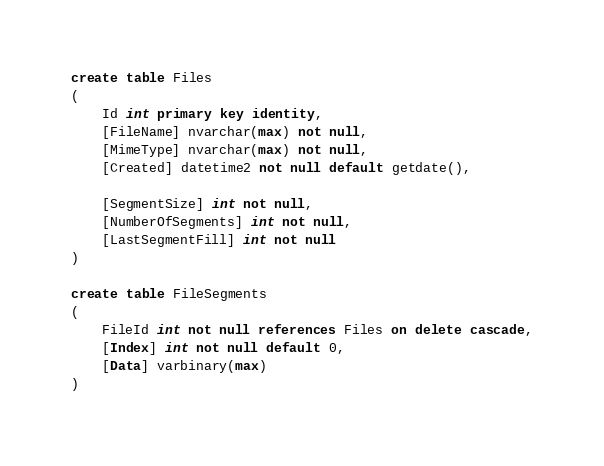<code> <loc_0><loc_0><loc_500><loc_500><_SQL_>create table Files
(
	Id int primary key identity,
	[FileName] nvarchar(max) not null,
	[MimeType] nvarchar(max) not null,
	[Created] datetime2 not null default getdate(),

	[SegmentSize] int not null,
	[NumberOfSegments] int not null,
	[LastSegmentFill] int not null
)

create table FileSegments
(
	FileId int not null references Files on delete cascade,
	[Index] int not null default 0,
	[Data] varbinary(max)
)</code> 